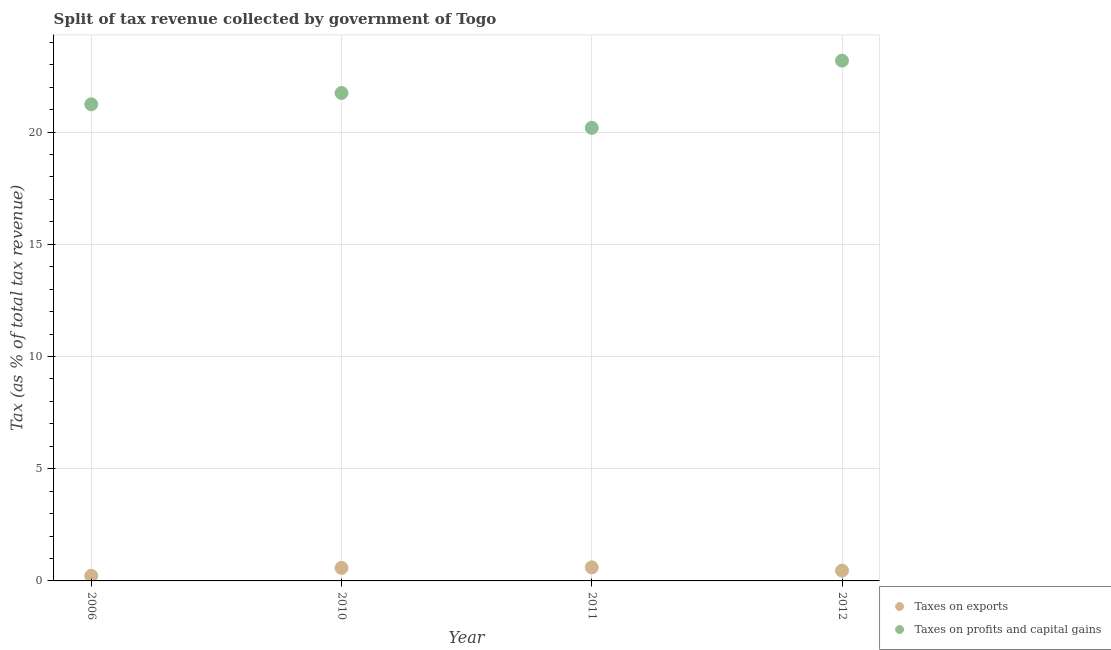What is the percentage of revenue obtained from taxes on exports in 2012?
Keep it short and to the point. 0.46. Across all years, what is the maximum percentage of revenue obtained from taxes on exports?
Your answer should be very brief. 0.6. Across all years, what is the minimum percentage of revenue obtained from taxes on exports?
Provide a succinct answer. 0.23. In which year was the percentage of revenue obtained from taxes on profits and capital gains minimum?
Make the answer very short. 2011. What is the total percentage of revenue obtained from taxes on exports in the graph?
Provide a short and direct response. 1.87. What is the difference between the percentage of revenue obtained from taxes on profits and capital gains in 2006 and that in 2010?
Your answer should be compact. -0.5. What is the difference between the percentage of revenue obtained from taxes on profits and capital gains in 2011 and the percentage of revenue obtained from taxes on exports in 2010?
Your answer should be compact. 19.61. What is the average percentage of revenue obtained from taxes on exports per year?
Your answer should be very brief. 0.47. In the year 2010, what is the difference between the percentage of revenue obtained from taxes on profits and capital gains and percentage of revenue obtained from taxes on exports?
Keep it short and to the point. 21.16. In how many years, is the percentage of revenue obtained from taxes on profits and capital gains greater than 13 %?
Offer a terse response. 4. What is the ratio of the percentage of revenue obtained from taxes on profits and capital gains in 2006 to that in 2011?
Make the answer very short. 1.05. Is the percentage of revenue obtained from taxes on exports in 2010 less than that in 2012?
Offer a very short reply. No. What is the difference between the highest and the second highest percentage of revenue obtained from taxes on profits and capital gains?
Make the answer very short. 1.44. What is the difference between the highest and the lowest percentage of revenue obtained from taxes on profits and capital gains?
Your response must be concise. 2.99. In how many years, is the percentage of revenue obtained from taxes on exports greater than the average percentage of revenue obtained from taxes on exports taken over all years?
Provide a short and direct response. 2. Is the sum of the percentage of revenue obtained from taxes on profits and capital gains in 2006 and 2011 greater than the maximum percentage of revenue obtained from taxes on exports across all years?
Your answer should be compact. Yes. Is the percentage of revenue obtained from taxes on exports strictly greater than the percentage of revenue obtained from taxes on profits and capital gains over the years?
Your response must be concise. No. How many dotlines are there?
Offer a terse response. 2. How many years are there in the graph?
Keep it short and to the point. 4. Are the values on the major ticks of Y-axis written in scientific E-notation?
Keep it short and to the point. No. Does the graph contain grids?
Give a very brief answer. Yes. How many legend labels are there?
Ensure brevity in your answer.  2. How are the legend labels stacked?
Make the answer very short. Vertical. What is the title of the graph?
Give a very brief answer. Split of tax revenue collected by government of Togo. Does "Primary income" appear as one of the legend labels in the graph?
Provide a succinct answer. No. What is the label or title of the Y-axis?
Make the answer very short. Tax (as % of total tax revenue). What is the Tax (as % of total tax revenue) in Taxes on exports in 2006?
Offer a very short reply. 0.23. What is the Tax (as % of total tax revenue) of Taxes on profits and capital gains in 2006?
Provide a short and direct response. 21.24. What is the Tax (as % of total tax revenue) of Taxes on exports in 2010?
Your answer should be very brief. 0.58. What is the Tax (as % of total tax revenue) of Taxes on profits and capital gains in 2010?
Your answer should be compact. 21.74. What is the Tax (as % of total tax revenue) of Taxes on exports in 2011?
Your answer should be compact. 0.6. What is the Tax (as % of total tax revenue) of Taxes on profits and capital gains in 2011?
Provide a succinct answer. 20.19. What is the Tax (as % of total tax revenue) in Taxes on exports in 2012?
Offer a terse response. 0.46. What is the Tax (as % of total tax revenue) of Taxes on profits and capital gains in 2012?
Provide a short and direct response. 23.18. Across all years, what is the maximum Tax (as % of total tax revenue) of Taxes on exports?
Your answer should be compact. 0.6. Across all years, what is the maximum Tax (as % of total tax revenue) of Taxes on profits and capital gains?
Ensure brevity in your answer.  23.18. Across all years, what is the minimum Tax (as % of total tax revenue) in Taxes on exports?
Provide a succinct answer. 0.23. Across all years, what is the minimum Tax (as % of total tax revenue) of Taxes on profits and capital gains?
Keep it short and to the point. 20.19. What is the total Tax (as % of total tax revenue) in Taxes on exports in the graph?
Make the answer very short. 1.87. What is the total Tax (as % of total tax revenue) of Taxes on profits and capital gains in the graph?
Offer a very short reply. 86.34. What is the difference between the Tax (as % of total tax revenue) in Taxes on exports in 2006 and that in 2010?
Keep it short and to the point. -0.35. What is the difference between the Tax (as % of total tax revenue) of Taxes on profits and capital gains in 2006 and that in 2010?
Offer a terse response. -0.5. What is the difference between the Tax (as % of total tax revenue) of Taxes on exports in 2006 and that in 2011?
Offer a terse response. -0.37. What is the difference between the Tax (as % of total tax revenue) of Taxes on profits and capital gains in 2006 and that in 2011?
Provide a short and direct response. 1.05. What is the difference between the Tax (as % of total tax revenue) in Taxes on exports in 2006 and that in 2012?
Ensure brevity in your answer.  -0.23. What is the difference between the Tax (as % of total tax revenue) in Taxes on profits and capital gains in 2006 and that in 2012?
Offer a terse response. -1.95. What is the difference between the Tax (as % of total tax revenue) in Taxes on exports in 2010 and that in 2011?
Make the answer very short. -0.02. What is the difference between the Tax (as % of total tax revenue) of Taxes on profits and capital gains in 2010 and that in 2011?
Ensure brevity in your answer.  1.55. What is the difference between the Tax (as % of total tax revenue) in Taxes on exports in 2010 and that in 2012?
Offer a terse response. 0.12. What is the difference between the Tax (as % of total tax revenue) in Taxes on profits and capital gains in 2010 and that in 2012?
Provide a short and direct response. -1.44. What is the difference between the Tax (as % of total tax revenue) of Taxes on exports in 2011 and that in 2012?
Your answer should be very brief. 0.14. What is the difference between the Tax (as % of total tax revenue) in Taxes on profits and capital gains in 2011 and that in 2012?
Offer a very short reply. -2.99. What is the difference between the Tax (as % of total tax revenue) in Taxes on exports in 2006 and the Tax (as % of total tax revenue) in Taxes on profits and capital gains in 2010?
Offer a very short reply. -21.51. What is the difference between the Tax (as % of total tax revenue) of Taxes on exports in 2006 and the Tax (as % of total tax revenue) of Taxes on profits and capital gains in 2011?
Give a very brief answer. -19.96. What is the difference between the Tax (as % of total tax revenue) in Taxes on exports in 2006 and the Tax (as % of total tax revenue) in Taxes on profits and capital gains in 2012?
Keep it short and to the point. -22.95. What is the difference between the Tax (as % of total tax revenue) of Taxes on exports in 2010 and the Tax (as % of total tax revenue) of Taxes on profits and capital gains in 2011?
Your answer should be very brief. -19.61. What is the difference between the Tax (as % of total tax revenue) of Taxes on exports in 2010 and the Tax (as % of total tax revenue) of Taxes on profits and capital gains in 2012?
Provide a short and direct response. -22.6. What is the difference between the Tax (as % of total tax revenue) of Taxes on exports in 2011 and the Tax (as % of total tax revenue) of Taxes on profits and capital gains in 2012?
Your answer should be very brief. -22.58. What is the average Tax (as % of total tax revenue) in Taxes on exports per year?
Make the answer very short. 0.47. What is the average Tax (as % of total tax revenue) in Taxes on profits and capital gains per year?
Provide a short and direct response. 21.59. In the year 2006, what is the difference between the Tax (as % of total tax revenue) of Taxes on exports and Tax (as % of total tax revenue) of Taxes on profits and capital gains?
Offer a very short reply. -21.01. In the year 2010, what is the difference between the Tax (as % of total tax revenue) of Taxes on exports and Tax (as % of total tax revenue) of Taxes on profits and capital gains?
Give a very brief answer. -21.16. In the year 2011, what is the difference between the Tax (as % of total tax revenue) in Taxes on exports and Tax (as % of total tax revenue) in Taxes on profits and capital gains?
Your answer should be very brief. -19.58. In the year 2012, what is the difference between the Tax (as % of total tax revenue) in Taxes on exports and Tax (as % of total tax revenue) in Taxes on profits and capital gains?
Give a very brief answer. -22.72. What is the ratio of the Tax (as % of total tax revenue) of Taxes on exports in 2006 to that in 2010?
Make the answer very short. 0.4. What is the ratio of the Tax (as % of total tax revenue) in Taxes on profits and capital gains in 2006 to that in 2010?
Your answer should be very brief. 0.98. What is the ratio of the Tax (as % of total tax revenue) of Taxes on exports in 2006 to that in 2011?
Make the answer very short. 0.38. What is the ratio of the Tax (as % of total tax revenue) in Taxes on profits and capital gains in 2006 to that in 2011?
Your answer should be very brief. 1.05. What is the ratio of the Tax (as % of total tax revenue) of Taxes on exports in 2006 to that in 2012?
Your answer should be very brief. 0.5. What is the ratio of the Tax (as % of total tax revenue) in Taxes on profits and capital gains in 2006 to that in 2012?
Make the answer very short. 0.92. What is the ratio of the Tax (as % of total tax revenue) in Taxes on exports in 2010 to that in 2011?
Your response must be concise. 0.96. What is the ratio of the Tax (as % of total tax revenue) of Taxes on exports in 2010 to that in 2012?
Provide a short and direct response. 1.26. What is the ratio of the Tax (as % of total tax revenue) of Taxes on profits and capital gains in 2010 to that in 2012?
Your answer should be compact. 0.94. What is the ratio of the Tax (as % of total tax revenue) in Taxes on exports in 2011 to that in 2012?
Your answer should be very brief. 1.31. What is the ratio of the Tax (as % of total tax revenue) in Taxes on profits and capital gains in 2011 to that in 2012?
Your response must be concise. 0.87. What is the difference between the highest and the second highest Tax (as % of total tax revenue) of Taxes on exports?
Provide a succinct answer. 0.02. What is the difference between the highest and the second highest Tax (as % of total tax revenue) of Taxes on profits and capital gains?
Give a very brief answer. 1.44. What is the difference between the highest and the lowest Tax (as % of total tax revenue) of Taxes on exports?
Keep it short and to the point. 0.37. What is the difference between the highest and the lowest Tax (as % of total tax revenue) of Taxes on profits and capital gains?
Offer a terse response. 2.99. 